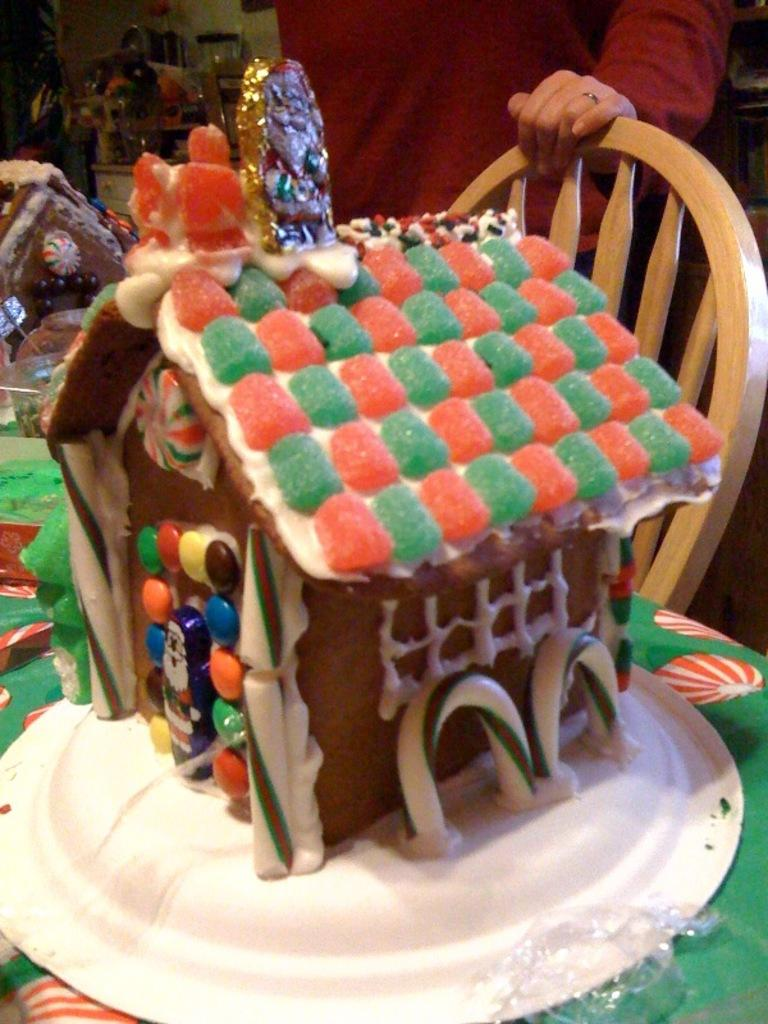What piece of furniture is present in the image? There is a table in the image. What is placed on the table? There is a plate on the table. What is on the plate? There is a cake in the plate. Is there any seating near the table? Yes, there is a chair beside the table. Who is present in the image? There is a person standing behind the chair. How many geese are present in the image? There are no geese present in the image. Does the existence of the cake in the plate prove the existence of dolls in the image? No, the existence of the cake in the plate does not prove the existence of dolls in the image, as dolls are not mentioned in the provided facts. 